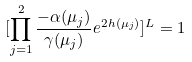Convert formula to latex. <formula><loc_0><loc_0><loc_500><loc_500>[ \prod _ { j = 1 } ^ { 2 } \frac { - \alpha ( \mu _ { j } ) } { \gamma ( \mu _ { j } ) } e ^ { 2 h ( \mu _ { j } ) } ] ^ { L } = 1</formula> 